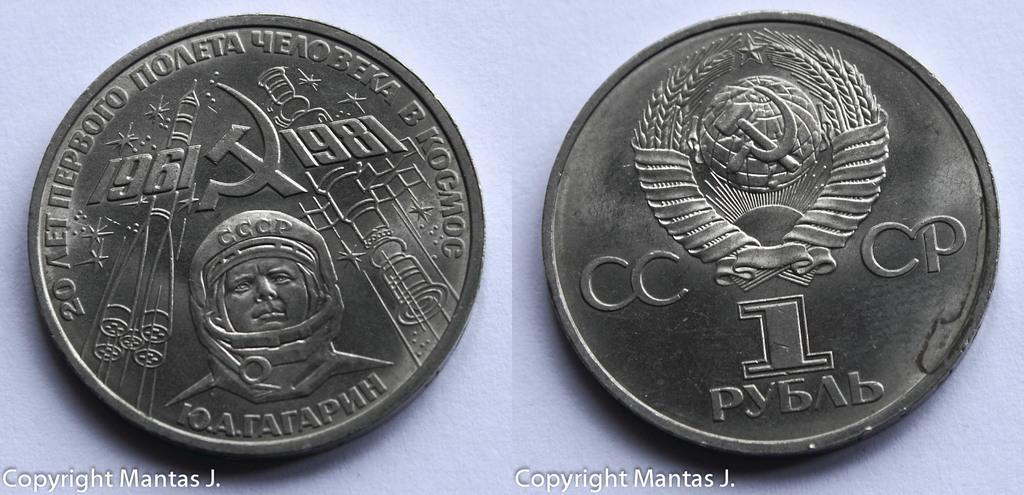What is the main feature of the image? The image contains a collage of two pictures. What objects are included in the collage? The collage includes coins. Is there any text present in the image? Yes, there is text at the bottom of the image. What type of suit is the person wearing in the image? There is no person present in the image, and therefore no suit can be observed. What number is associated with the collage in the image? There is no specific number associated with the collage in the image. 